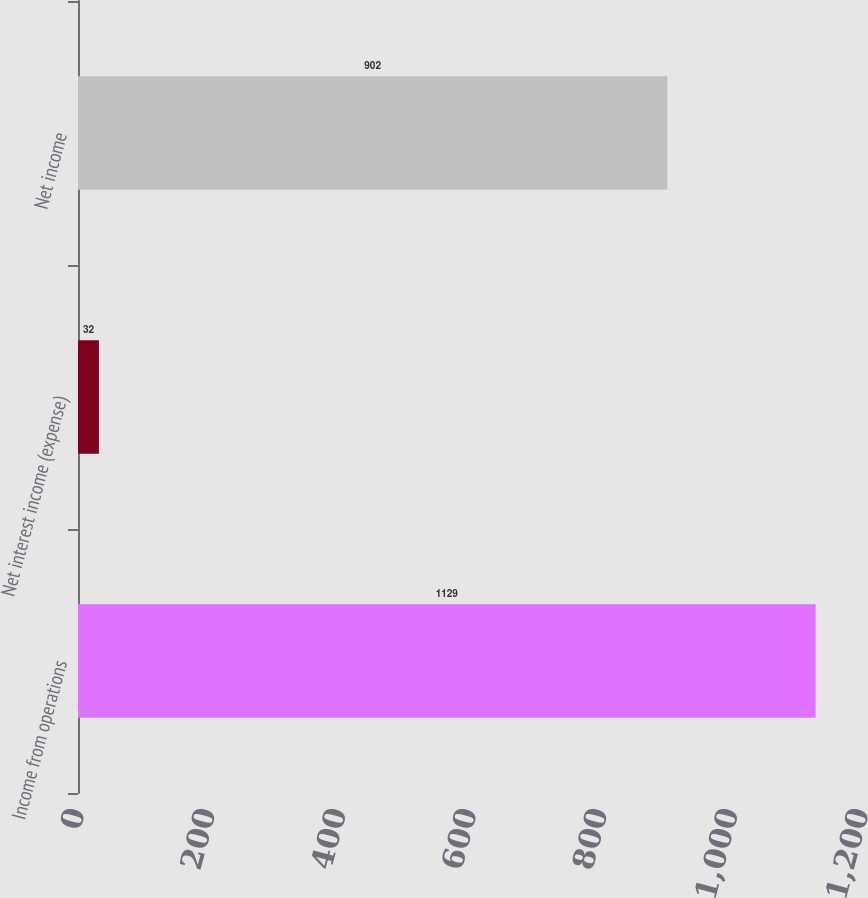<chart> <loc_0><loc_0><loc_500><loc_500><bar_chart><fcel>Income from operations<fcel>Net interest income (expense)<fcel>Net income<nl><fcel>1129<fcel>32<fcel>902<nl></chart> 